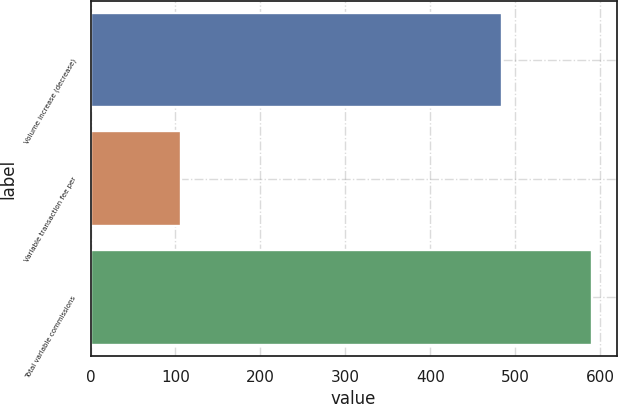Convert chart to OTSL. <chart><loc_0><loc_0><loc_500><loc_500><bar_chart><fcel>Volume increase (decrease)<fcel>Variable transaction fee per<fcel>Total variable commissions<nl><fcel>484<fcel>106<fcel>590<nl></chart> 